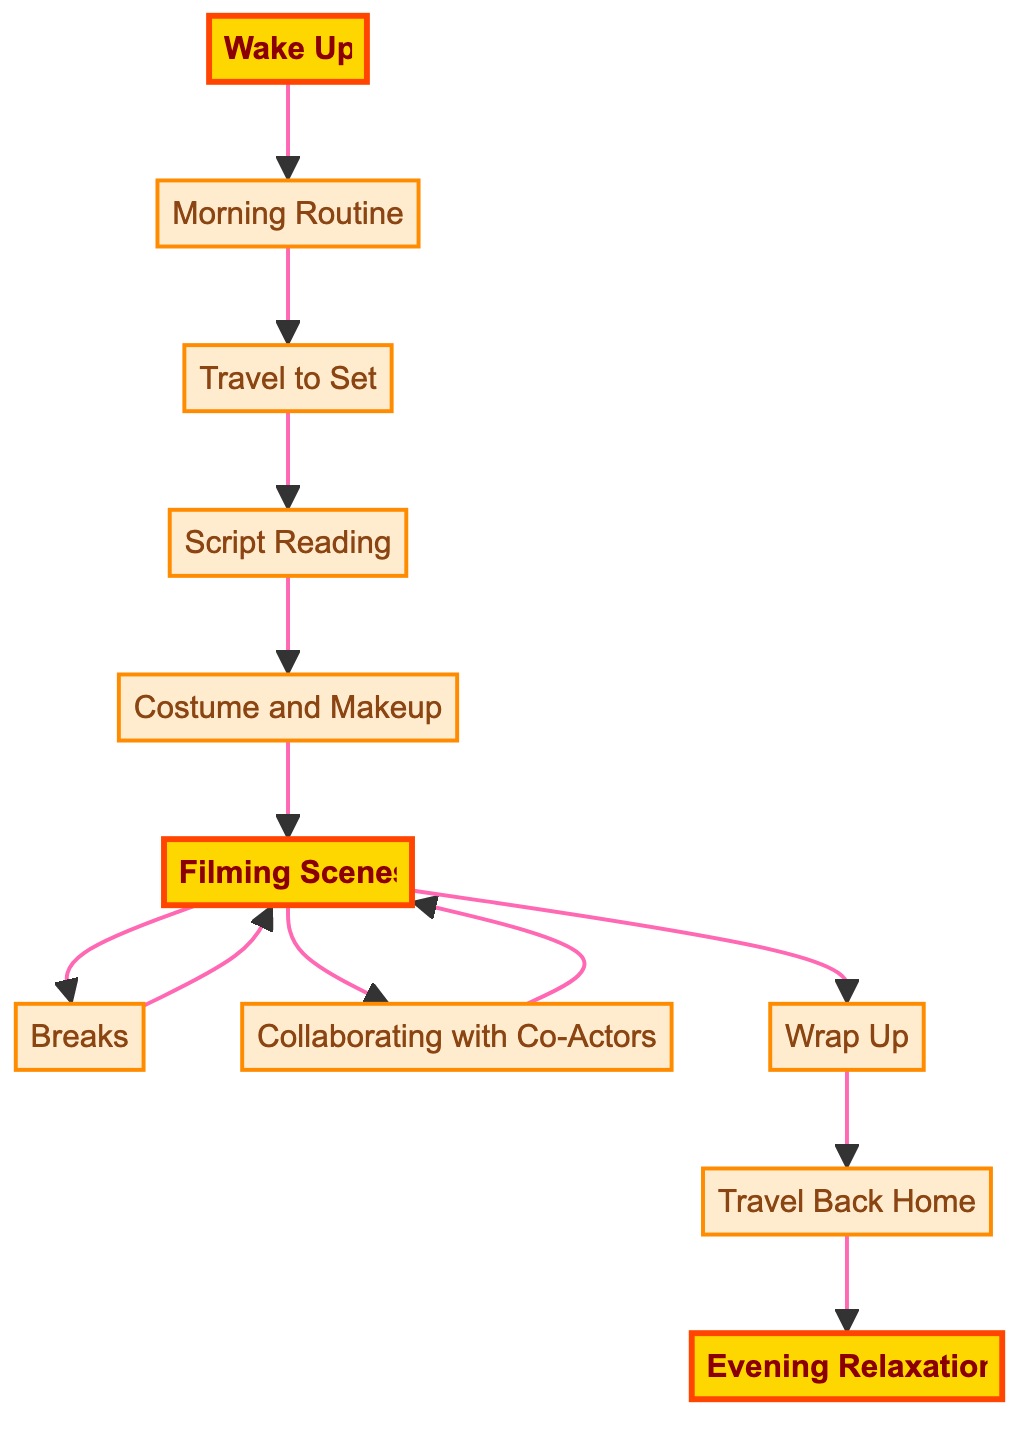What is the first activity depicted in the diagram? The diagram indicates that the first activity is "Wake Up." This is the starting point and is shown at the top of the flowchart.
Answer: Wake Up How many main activities are there in the diagram? By counting each unique element or node in the diagram, there are a total of 11 activities listed. These include "Wake Up," "Morning Routine," and others until "Evening Relaxation."
Answer: 11 Which activity immediately follows "Travel to Set"? According to the flowchart, after "Travel to Set," the next activity depicted is "Script Reading." This shows a direct connection in the sequence of activities.
Answer: Script Reading What happens after "Filming Scenes"? Following "Filming Scenes," the diagram indicates "Breaks" as the next activity. This sequence shows that breaks are part of the filming process.
Answer: Breaks What is the last activity before "Evening Relaxation"? The diagram illustrates that the last activity prior to "Evening Relaxation" is "Travel Back Home." This activity concludes the day's filming schedule before the actor relaxes in the evening.
Answer: Travel Back Home How many times does "Filming Scenes" connect to other activities? The "Filming Scenes" node connects to three other activities: "Breaks," "Collaborating with Co-Actors," and "Wrap Up." These connections indicate its key role in the daily schedule.
Answer: 3 What link is highlighted in the diagram? The links directed to "Wake Up," "Filming Scenes," and "Evening Relaxation" are highlighted, indicating they are significant points within the flow of a Bollywood actor's day.
Answer: Wake Up, Filming Scenes, Evening Relaxation After "Breaks," which activity does the flow return to? The flowchart shows that after "Breaks," the activity loops back to "Filming Scenes," signifying that after taking breaks, the actor resumes shooting.
Answer: Filming Scenes 